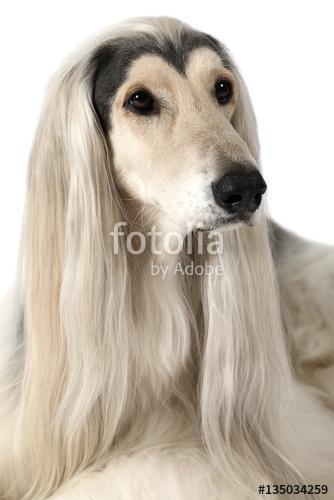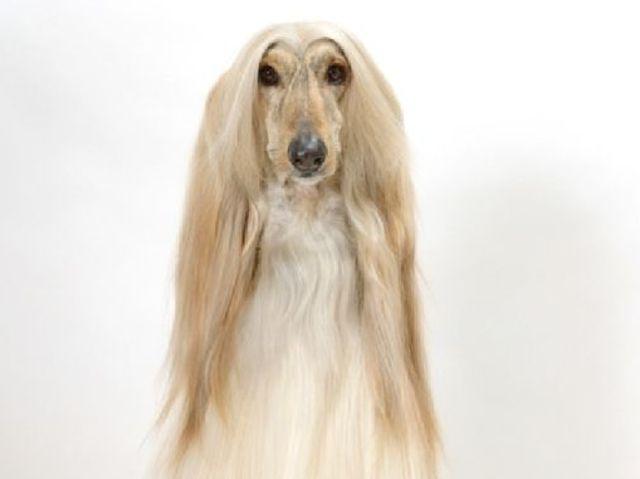The first image is the image on the left, the second image is the image on the right. Given the left and right images, does the statement "The dog in the image on the right has a white coat." hold true? Answer yes or no. No. 